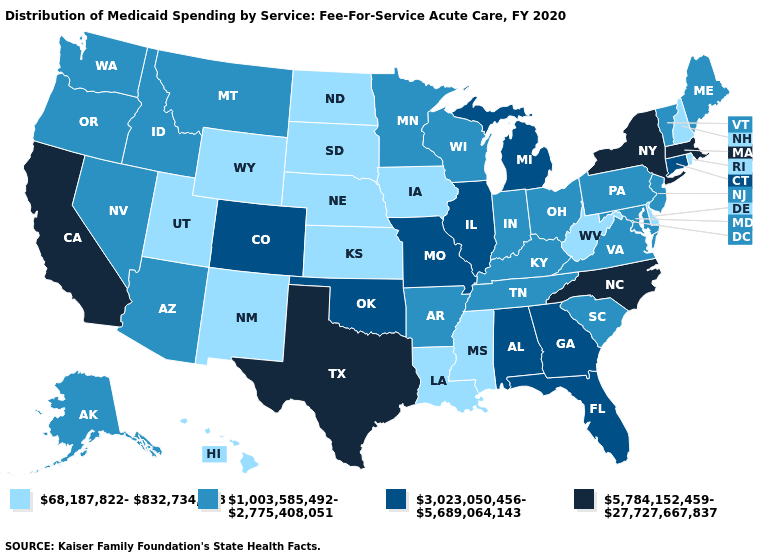What is the value of Iowa?
Answer briefly. 68,187,822-832,734,728. What is the highest value in the USA?
Give a very brief answer. 5,784,152,459-27,727,667,837. How many symbols are there in the legend?
Give a very brief answer. 4. Does Mississippi have the lowest value in the South?
Be succinct. Yes. Among the states that border Florida , which have the highest value?
Answer briefly. Alabama, Georgia. Does Rhode Island have a higher value than Colorado?
Quick response, please. No. What is the lowest value in the USA?
Answer briefly. 68,187,822-832,734,728. What is the highest value in the USA?
Quick response, please. 5,784,152,459-27,727,667,837. Does the first symbol in the legend represent the smallest category?
Give a very brief answer. Yes. Does the first symbol in the legend represent the smallest category?
Keep it brief. Yes. What is the value of Tennessee?
Answer briefly. 1,003,585,492-2,775,408,051. Name the states that have a value in the range 3,023,050,456-5,689,064,143?
Concise answer only. Alabama, Colorado, Connecticut, Florida, Georgia, Illinois, Michigan, Missouri, Oklahoma. Name the states that have a value in the range 1,003,585,492-2,775,408,051?
Short answer required. Alaska, Arizona, Arkansas, Idaho, Indiana, Kentucky, Maine, Maryland, Minnesota, Montana, Nevada, New Jersey, Ohio, Oregon, Pennsylvania, South Carolina, Tennessee, Vermont, Virginia, Washington, Wisconsin. Name the states that have a value in the range 5,784,152,459-27,727,667,837?
Be succinct. California, Massachusetts, New York, North Carolina, Texas. What is the value of Maine?
Write a very short answer. 1,003,585,492-2,775,408,051. 